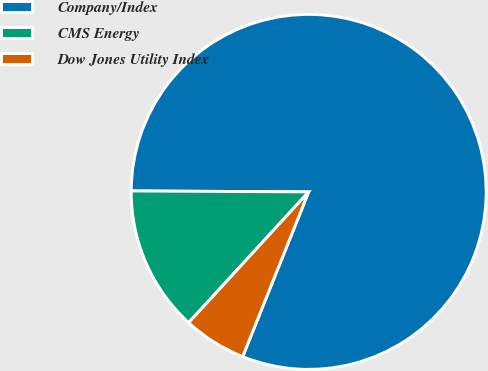Convert chart. <chart><loc_0><loc_0><loc_500><loc_500><pie_chart><fcel>Company/Index<fcel>CMS Energy<fcel>Dow Jones Utility Index<nl><fcel>80.98%<fcel>13.27%<fcel>5.75%<nl></chart> 